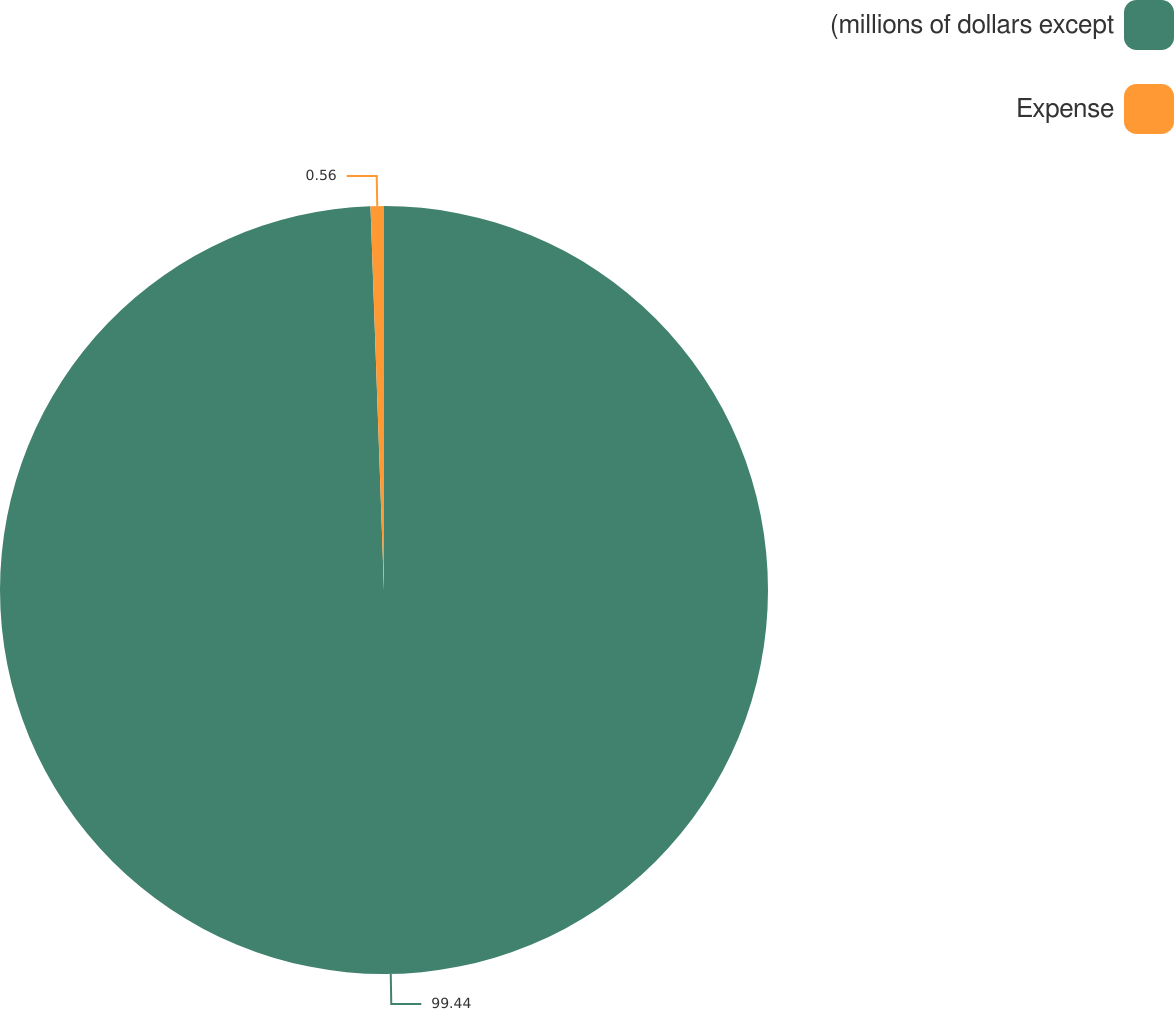Convert chart to OTSL. <chart><loc_0><loc_0><loc_500><loc_500><pie_chart><fcel>(millions of dollars except<fcel>Expense<nl><fcel>99.44%<fcel>0.56%<nl></chart> 